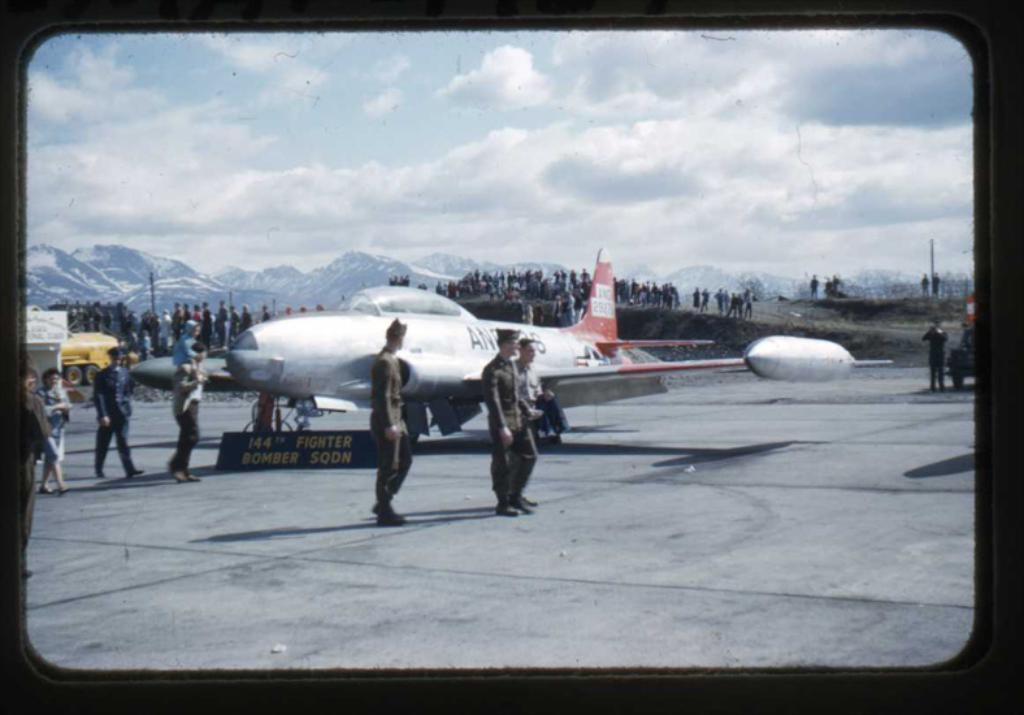What is the main subject of the image? The main subject of the image is an airplane. Can you describe the people in the image? There are people in the image, but their specific actions or appearances are not mentioned in the facts. What other objects or vehicles are present in the image? There are vehicles in the image, but their specific types or appearances are not mentioned in the facts. What is written on the board in the image? The facts mention that there is a board with some text in the image, but the specific text is not provided. What can be seen in the sky in the image? The sky is visible in the image, but the specific weather or cloud conditions are not mentioned in the facts. What type of animal is being carried in a parcel by one of the people in the image? There is no mention of an animal or a parcel in the image, so this question cannot be answered based on the provided facts. 